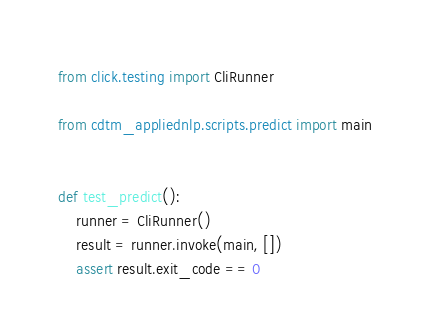<code> <loc_0><loc_0><loc_500><loc_500><_Python_>from click.testing import CliRunner

from cdtm_appliednlp.scripts.predict import main


def test_predict():
    runner = CliRunner()
    result = runner.invoke(main, [])
    assert result.exit_code == 0
</code> 